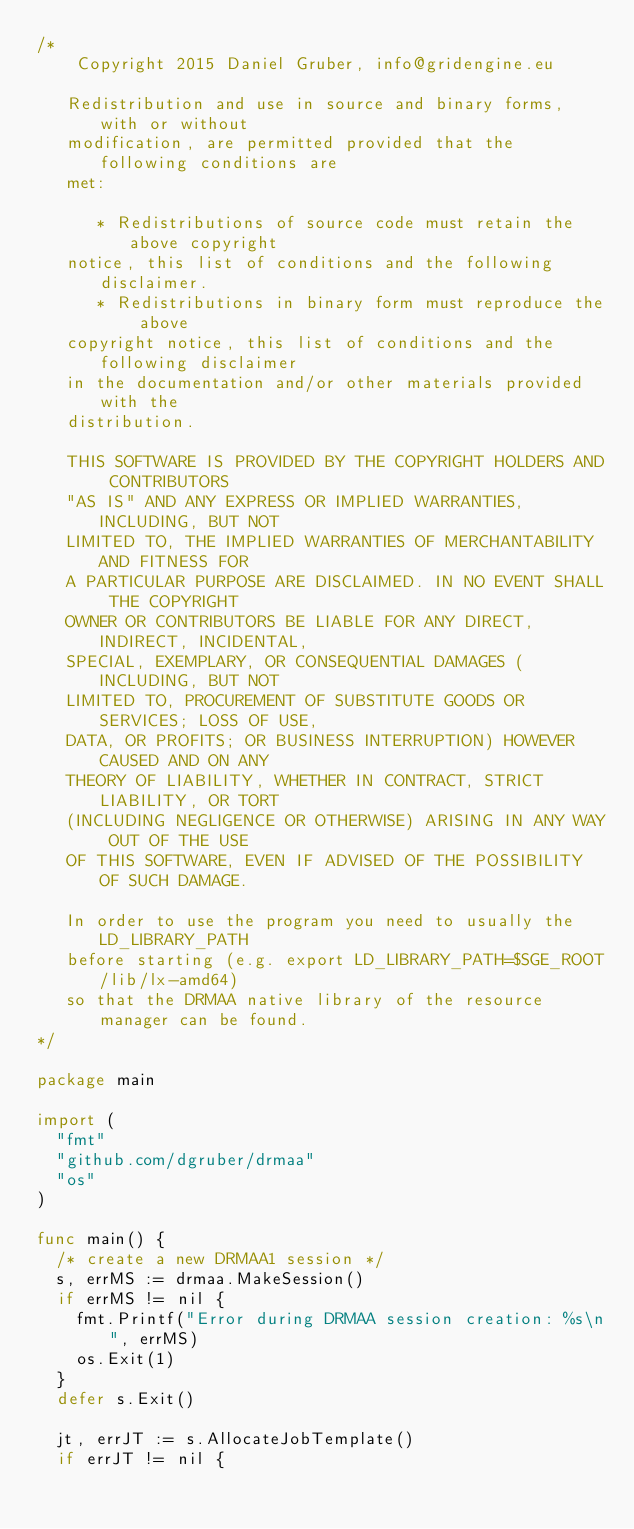<code> <loc_0><loc_0><loc_500><loc_500><_Go_>/*
    Copyright 2015 Daniel Gruber, info@gridengine.eu

   Redistribution and use in source and binary forms, with or without
   modification, are permitted provided that the following conditions are
   met:

      * Redistributions of source code must retain the above copyright
   notice, this list of conditions and the following disclaimer.
      * Redistributions in binary form must reproduce the above
   copyright notice, this list of conditions and the following disclaimer
   in the documentation and/or other materials provided with the
   distribution.

   THIS SOFTWARE IS PROVIDED BY THE COPYRIGHT HOLDERS AND CONTRIBUTORS
   "AS IS" AND ANY EXPRESS OR IMPLIED WARRANTIES, INCLUDING, BUT NOT
   LIMITED TO, THE IMPLIED WARRANTIES OF MERCHANTABILITY AND FITNESS FOR
   A PARTICULAR PURPOSE ARE DISCLAIMED. IN NO EVENT SHALL THE COPYRIGHT
   OWNER OR CONTRIBUTORS BE LIABLE FOR ANY DIRECT, INDIRECT, INCIDENTAL,
   SPECIAL, EXEMPLARY, OR CONSEQUENTIAL DAMAGES (INCLUDING, BUT NOT
   LIMITED TO, PROCUREMENT OF SUBSTITUTE GOODS OR SERVICES; LOSS OF USE,
   DATA, OR PROFITS; OR BUSINESS INTERRUPTION) HOWEVER CAUSED AND ON ANY
   THEORY OF LIABILITY, WHETHER IN CONTRACT, STRICT LIABILITY, OR TORT
   (INCLUDING NEGLIGENCE OR OTHERWISE) ARISING IN ANY WAY OUT OF THE USE
   OF THIS SOFTWARE, EVEN IF ADVISED OF THE POSSIBILITY OF SUCH DAMAGE.

   In order to use the program you need to usually the LD_LIBRARY_PATH
   before starting (e.g. export LD_LIBRARY_PATH=$SGE_ROOT/lib/lx-amd64)
   so that the DRMAA native library of the resource manager can be found.
*/

package main

import (
	"fmt"
	"github.com/dgruber/drmaa"
	"os"
)

func main() {
	/* create a new DRMAA1 session */
	s, errMS := drmaa.MakeSession()
	if errMS != nil {
		fmt.Printf("Error during DRMAA session creation: %s\n", errMS)
		os.Exit(1)
	}
	defer s.Exit()

	jt, errJT := s.AllocateJobTemplate()
	if errJT != nil {</code> 